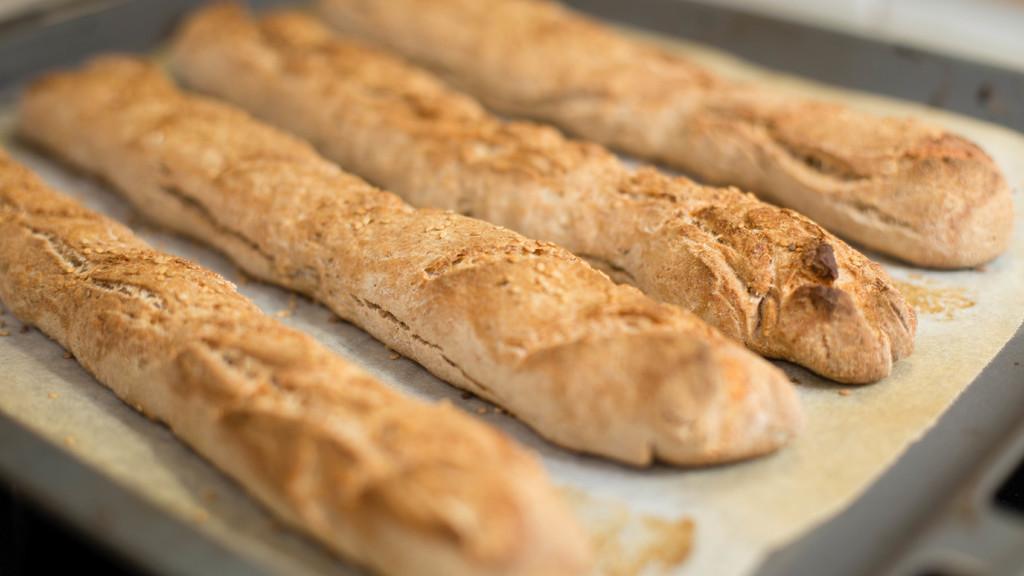Can you describe this image briefly? In this image we can see there are so many breadsticks on the plate. 